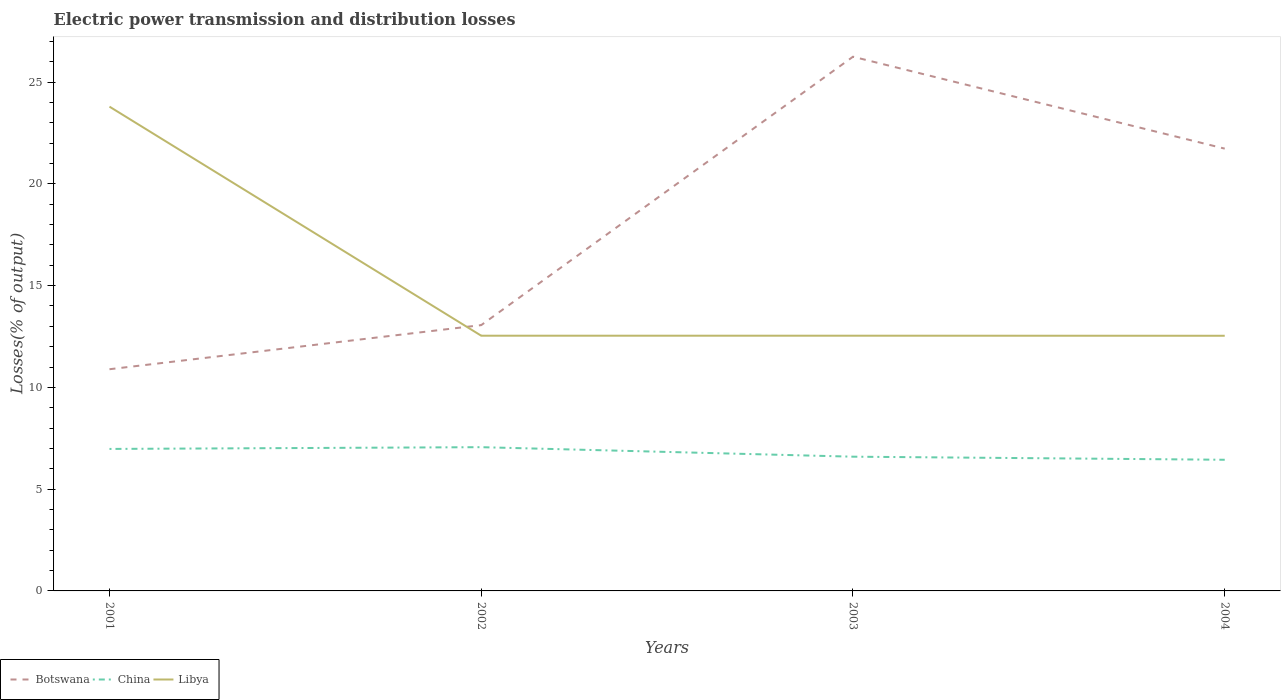How many different coloured lines are there?
Make the answer very short. 3. Does the line corresponding to Botswana intersect with the line corresponding to Libya?
Provide a succinct answer. Yes. Across all years, what is the maximum electric power transmission and distribution losses in Libya?
Your response must be concise. 12.54. In which year was the electric power transmission and distribution losses in Libya maximum?
Offer a very short reply. 2004. What is the total electric power transmission and distribution losses in Botswana in the graph?
Your answer should be very brief. -8.67. What is the difference between the highest and the second highest electric power transmission and distribution losses in China?
Provide a short and direct response. 0.62. What is the difference between the highest and the lowest electric power transmission and distribution losses in Botswana?
Offer a terse response. 2. How many lines are there?
Offer a terse response. 3. Where does the legend appear in the graph?
Keep it short and to the point. Bottom left. How are the legend labels stacked?
Provide a short and direct response. Horizontal. What is the title of the graph?
Offer a very short reply. Electric power transmission and distribution losses. Does "Timor-Leste" appear as one of the legend labels in the graph?
Offer a terse response. No. What is the label or title of the X-axis?
Ensure brevity in your answer.  Years. What is the label or title of the Y-axis?
Your answer should be very brief. Losses(% of output). What is the Losses(% of output) in Botswana in 2001?
Your answer should be compact. 10.89. What is the Losses(% of output) of China in 2001?
Provide a short and direct response. 6.98. What is the Losses(% of output) in Libya in 2001?
Make the answer very short. 23.79. What is the Losses(% of output) in Botswana in 2002?
Your response must be concise. 13.06. What is the Losses(% of output) in China in 2002?
Your response must be concise. 7.06. What is the Losses(% of output) in Libya in 2002?
Make the answer very short. 12.54. What is the Losses(% of output) in Botswana in 2003?
Offer a very short reply. 26.24. What is the Losses(% of output) of China in 2003?
Provide a succinct answer. 6.59. What is the Losses(% of output) in Libya in 2003?
Keep it short and to the point. 12.54. What is the Losses(% of output) of Botswana in 2004?
Provide a short and direct response. 21.73. What is the Losses(% of output) in China in 2004?
Make the answer very short. 6.44. What is the Losses(% of output) of Libya in 2004?
Make the answer very short. 12.54. Across all years, what is the maximum Losses(% of output) of Botswana?
Provide a succinct answer. 26.24. Across all years, what is the maximum Losses(% of output) of China?
Offer a terse response. 7.06. Across all years, what is the maximum Losses(% of output) in Libya?
Give a very brief answer. 23.79. Across all years, what is the minimum Losses(% of output) of Botswana?
Provide a short and direct response. 10.89. Across all years, what is the minimum Losses(% of output) in China?
Your response must be concise. 6.44. Across all years, what is the minimum Losses(% of output) in Libya?
Provide a short and direct response. 12.54. What is the total Losses(% of output) of Botswana in the graph?
Give a very brief answer. 71.92. What is the total Losses(% of output) of China in the graph?
Give a very brief answer. 27.08. What is the total Losses(% of output) in Libya in the graph?
Keep it short and to the point. 61.4. What is the difference between the Losses(% of output) of Botswana in 2001 and that in 2002?
Your answer should be compact. -2.17. What is the difference between the Losses(% of output) of China in 2001 and that in 2002?
Ensure brevity in your answer.  -0.09. What is the difference between the Losses(% of output) in Libya in 2001 and that in 2002?
Offer a terse response. 11.25. What is the difference between the Losses(% of output) in Botswana in 2001 and that in 2003?
Your response must be concise. -15.35. What is the difference between the Losses(% of output) in China in 2001 and that in 2003?
Your answer should be very brief. 0.38. What is the difference between the Losses(% of output) of Libya in 2001 and that in 2003?
Your answer should be very brief. 11.25. What is the difference between the Losses(% of output) of Botswana in 2001 and that in 2004?
Offer a terse response. -10.84. What is the difference between the Losses(% of output) in China in 2001 and that in 2004?
Provide a succinct answer. 0.53. What is the difference between the Losses(% of output) in Libya in 2001 and that in 2004?
Ensure brevity in your answer.  11.26. What is the difference between the Losses(% of output) in Botswana in 2002 and that in 2003?
Give a very brief answer. -13.19. What is the difference between the Losses(% of output) in China in 2002 and that in 2003?
Offer a very short reply. 0.47. What is the difference between the Losses(% of output) in Botswana in 2002 and that in 2004?
Provide a succinct answer. -8.67. What is the difference between the Losses(% of output) of China in 2002 and that in 2004?
Your answer should be compact. 0.62. What is the difference between the Losses(% of output) in Libya in 2002 and that in 2004?
Make the answer very short. 0. What is the difference between the Losses(% of output) of Botswana in 2003 and that in 2004?
Ensure brevity in your answer.  4.51. What is the difference between the Losses(% of output) of China in 2003 and that in 2004?
Offer a very short reply. 0.15. What is the difference between the Losses(% of output) of Libya in 2003 and that in 2004?
Offer a terse response. 0. What is the difference between the Losses(% of output) in Botswana in 2001 and the Losses(% of output) in China in 2002?
Offer a very short reply. 3.83. What is the difference between the Losses(% of output) of Botswana in 2001 and the Losses(% of output) of Libya in 2002?
Give a very brief answer. -1.65. What is the difference between the Losses(% of output) in China in 2001 and the Losses(% of output) in Libya in 2002?
Your response must be concise. -5.56. What is the difference between the Losses(% of output) in Botswana in 2001 and the Losses(% of output) in China in 2003?
Offer a very short reply. 4.3. What is the difference between the Losses(% of output) of Botswana in 2001 and the Losses(% of output) of Libya in 2003?
Provide a short and direct response. -1.65. What is the difference between the Losses(% of output) of China in 2001 and the Losses(% of output) of Libya in 2003?
Provide a short and direct response. -5.56. What is the difference between the Losses(% of output) in Botswana in 2001 and the Losses(% of output) in China in 2004?
Make the answer very short. 4.45. What is the difference between the Losses(% of output) of Botswana in 2001 and the Losses(% of output) of Libya in 2004?
Make the answer very short. -1.64. What is the difference between the Losses(% of output) in China in 2001 and the Losses(% of output) in Libya in 2004?
Make the answer very short. -5.56. What is the difference between the Losses(% of output) of Botswana in 2002 and the Losses(% of output) of China in 2003?
Give a very brief answer. 6.46. What is the difference between the Losses(% of output) in Botswana in 2002 and the Losses(% of output) in Libya in 2003?
Provide a short and direct response. 0.52. What is the difference between the Losses(% of output) of China in 2002 and the Losses(% of output) of Libya in 2003?
Offer a very short reply. -5.48. What is the difference between the Losses(% of output) in Botswana in 2002 and the Losses(% of output) in China in 2004?
Your response must be concise. 6.61. What is the difference between the Losses(% of output) of Botswana in 2002 and the Losses(% of output) of Libya in 2004?
Offer a very short reply. 0.52. What is the difference between the Losses(% of output) of China in 2002 and the Losses(% of output) of Libya in 2004?
Give a very brief answer. -5.47. What is the difference between the Losses(% of output) of Botswana in 2003 and the Losses(% of output) of China in 2004?
Ensure brevity in your answer.  19.8. What is the difference between the Losses(% of output) in Botswana in 2003 and the Losses(% of output) in Libya in 2004?
Provide a short and direct response. 13.71. What is the difference between the Losses(% of output) in China in 2003 and the Losses(% of output) in Libya in 2004?
Give a very brief answer. -5.94. What is the average Losses(% of output) in Botswana per year?
Provide a short and direct response. 17.98. What is the average Losses(% of output) in China per year?
Your response must be concise. 6.77. What is the average Losses(% of output) in Libya per year?
Provide a short and direct response. 15.35. In the year 2001, what is the difference between the Losses(% of output) of Botswana and Losses(% of output) of China?
Provide a succinct answer. 3.92. In the year 2001, what is the difference between the Losses(% of output) of Botswana and Losses(% of output) of Libya?
Offer a very short reply. -12.9. In the year 2001, what is the difference between the Losses(% of output) in China and Losses(% of output) in Libya?
Give a very brief answer. -16.82. In the year 2002, what is the difference between the Losses(% of output) in Botswana and Losses(% of output) in China?
Your answer should be compact. 6. In the year 2002, what is the difference between the Losses(% of output) of Botswana and Losses(% of output) of Libya?
Offer a very short reply. 0.52. In the year 2002, what is the difference between the Losses(% of output) in China and Losses(% of output) in Libya?
Keep it short and to the point. -5.48. In the year 2003, what is the difference between the Losses(% of output) in Botswana and Losses(% of output) in China?
Give a very brief answer. 19.65. In the year 2003, what is the difference between the Losses(% of output) of Botswana and Losses(% of output) of Libya?
Offer a very short reply. 13.71. In the year 2003, what is the difference between the Losses(% of output) of China and Losses(% of output) of Libya?
Offer a terse response. -5.94. In the year 2004, what is the difference between the Losses(% of output) of Botswana and Losses(% of output) of China?
Provide a short and direct response. 15.28. In the year 2004, what is the difference between the Losses(% of output) in Botswana and Losses(% of output) in Libya?
Keep it short and to the point. 9.19. In the year 2004, what is the difference between the Losses(% of output) in China and Losses(% of output) in Libya?
Provide a short and direct response. -6.09. What is the ratio of the Losses(% of output) in Botswana in 2001 to that in 2002?
Your answer should be compact. 0.83. What is the ratio of the Losses(% of output) in China in 2001 to that in 2002?
Your response must be concise. 0.99. What is the ratio of the Losses(% of output) of Libya in 2001 to that in 2002?
Your answer should be very brief. 1.9. What is the ratio of the Losses(% of output) of Botswana in 2001 to that in 2003?
Your answer should be compact. 0.41. What is the ratio of the Losses(% of output) in China in 2001 to that in 2003?
Provide a short and direct response. 1.06. What is the ratio of the Losses(% of output) of Libya in 2001 to that in 2003?
Your answer should be compact. 1.9. What is the ratio of the Losses(% of output) in Botswana in 2001 to that in 2004?
Your answer should be very brief. 0.5. What is the ratio of the Losses(% of output) of China in 2001 to that in 2004?
Offer a very short reply. 1.08. What is the ratio of the Losses(% of output) of Libya in 2001 to that in 2004?
Give a very brief answer. 1.9. What is the ratio of the Losses(% of output) of Botswana in 2002 to that in 2003?
Ensure brevity in your answer.  0.5. What is the ratio of the Losses(% of output) of China in 2002 to that in 2003?
Your response must be concise. 1.07. What is the ratio of the Losses(% of output) in Libya in 2002 to that in 2003?
Provide a short and direct response. 1. What is the ratio of the Losses(% of output) of Botswana in 2002 to that in 2004?
Offer a very short reply. 0.6. What is the ratio of the Losses(% of output) of China in 2002 to that in 2004?
Give a very brief answer. 1.1. What is the ratio of the Losses(% of output) of Libya in 2002 to that in 2004?
Give a very brief answer. 1. What is the ratio of the Losses(% of output) in Botswana in 2003 to that in 2004?
Offer a very short reply. 1.21. What is the ratio of the Losses(% of output) of China in 2003 to that in 2004?
Your response must be concise. 1.02. What is the difference between the highest and the second highest Losses(% of output) of Botswana?
Provide a succinct answer. 4.51. What is the difference between the highest and the second highest Losses(% of output) in China?
Your response must be concise. 0.09. What is the difference between the highest and the second highest Losses(% of output) of Libya?
Provide a short and direct response. 11.25. What is the difference between the highest and the lowest Losses(% of output) in Botswana?
Give a very brief answer. 15.35. What is the difference between the highest and the lowest Losses(% of output) in China?
Make the answer very short. 0.62. What is the difference between the highest and the lowest Losses(% of output) of Libya?
Give a very brief answer. 11.26. 